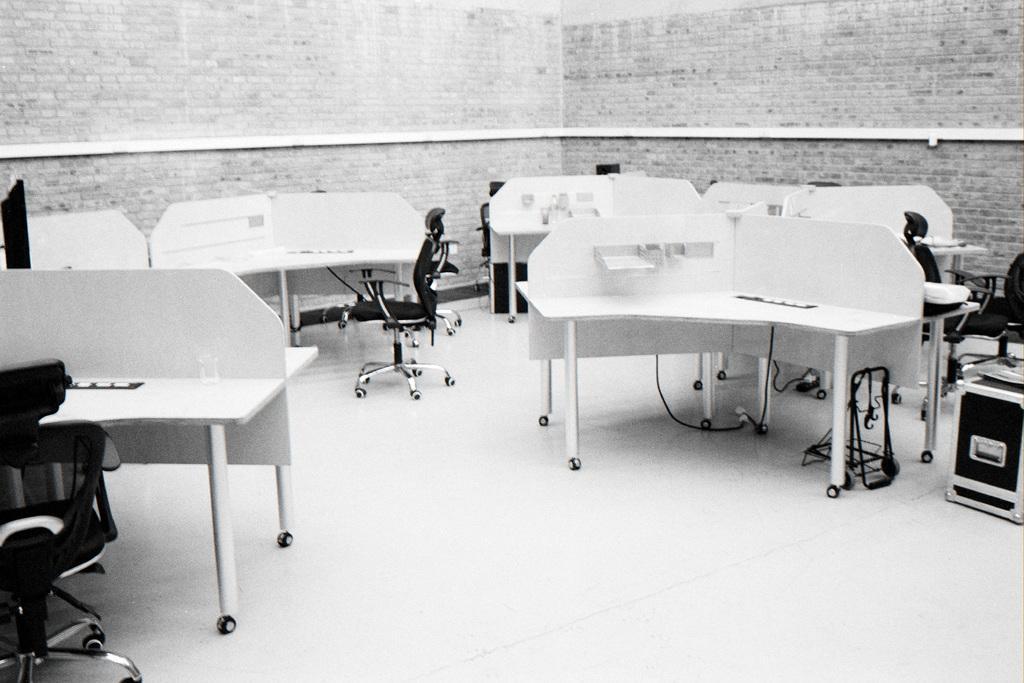Could you give a brief overview of what you see in this image? These are tables and chairs. 